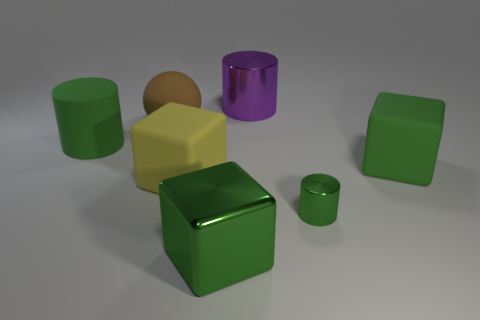Add 2 gray matte objects. How many objects exist? 9 Subtract all cylinders. How many objects are left? 4 Add 2 big green metal blocks. How many big green metal blocks are left? 3 Add 3 big green metal cylinders. How many big green metal cylinders exist? 3 Subtract 0 cyan blocks. How many objects are left? 7 Subtract all large green rubber cylinders. Subtract all green metal cubes. How many objects are left? 5 